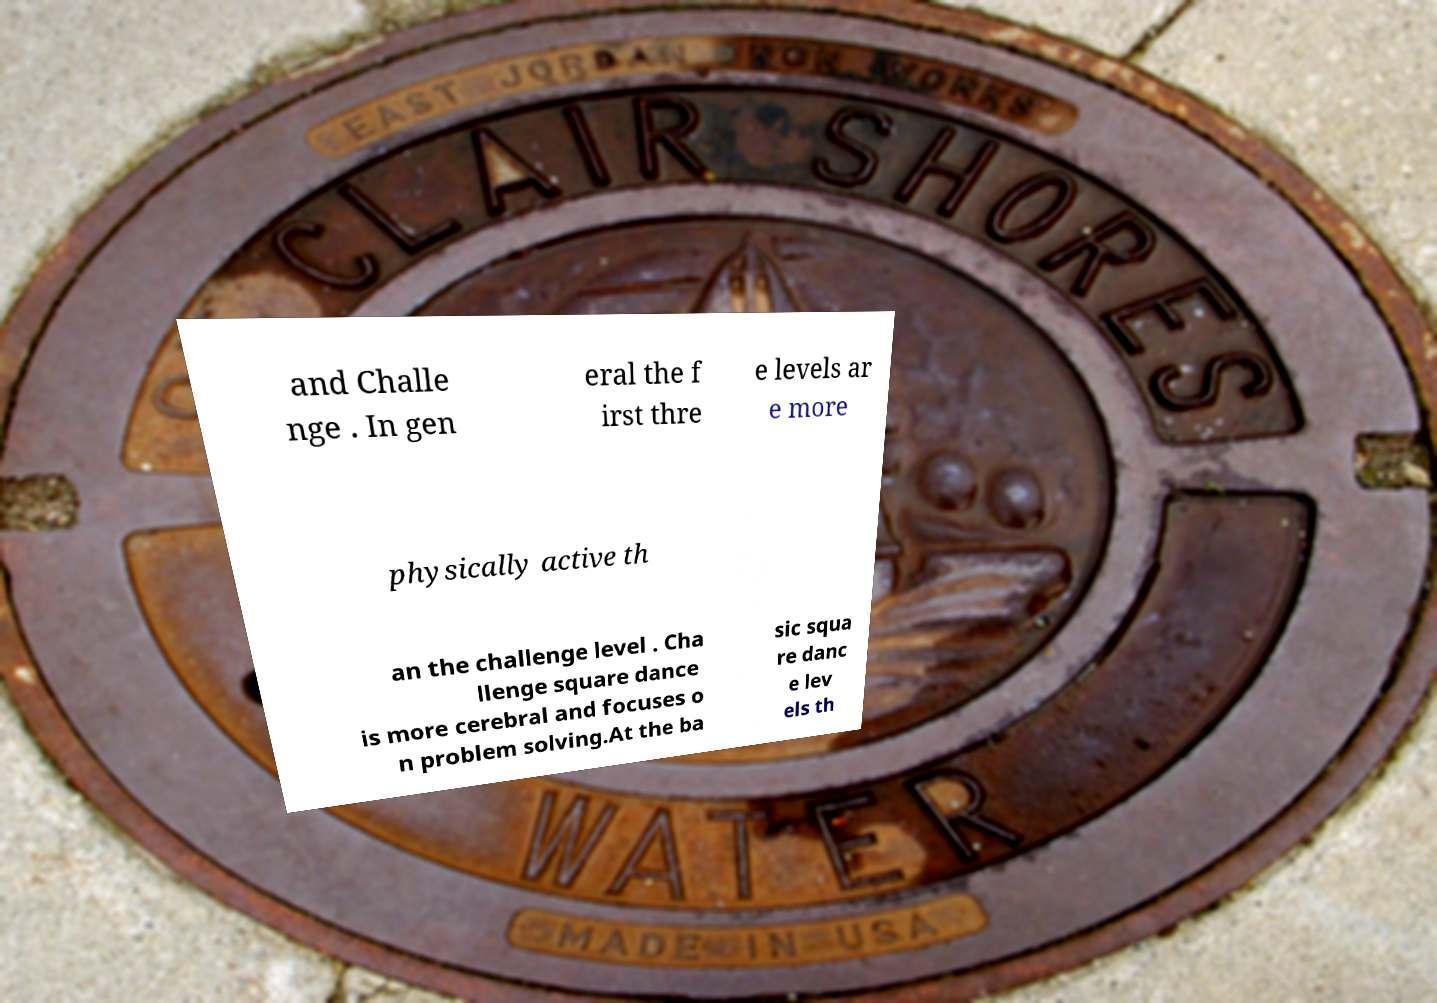Could you assist in decoding the text presented in this image and type it out clearly? and Challe nge . In gen eral the f irst thre e levels ar e more physically active th an the challenge level . Cha llenge square dance is more cerebral and focuses o n problem solving.At the ba sic squa re danc e lev els th 